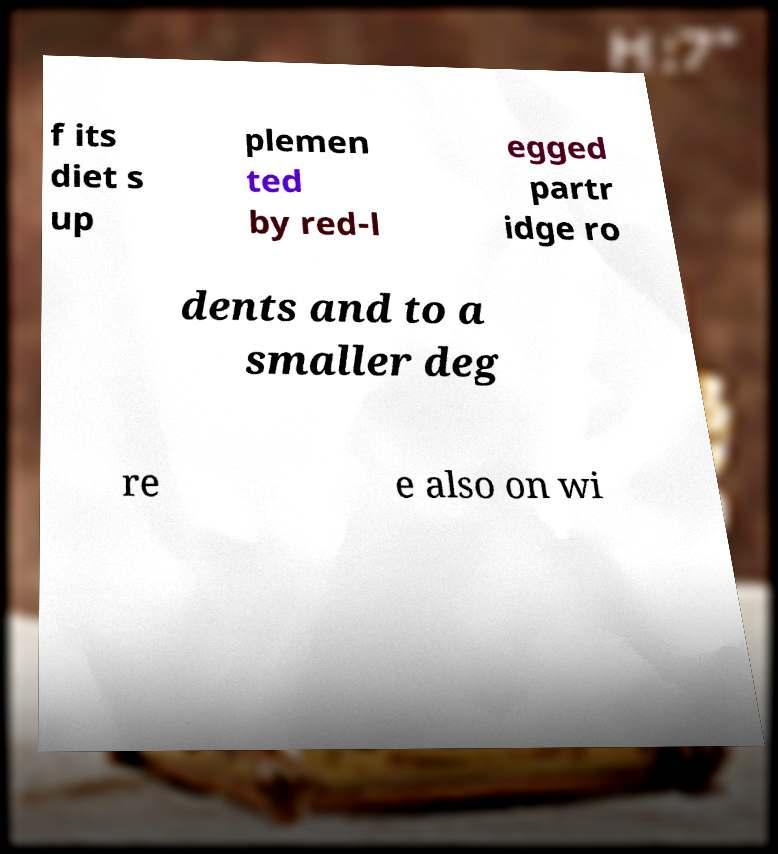What messages or text are displayed in this image? I need them in a readable, typed format. f its diet s up plemen ted by red-l egged partr idge ro dents and to a smaller deg re e also on wi 